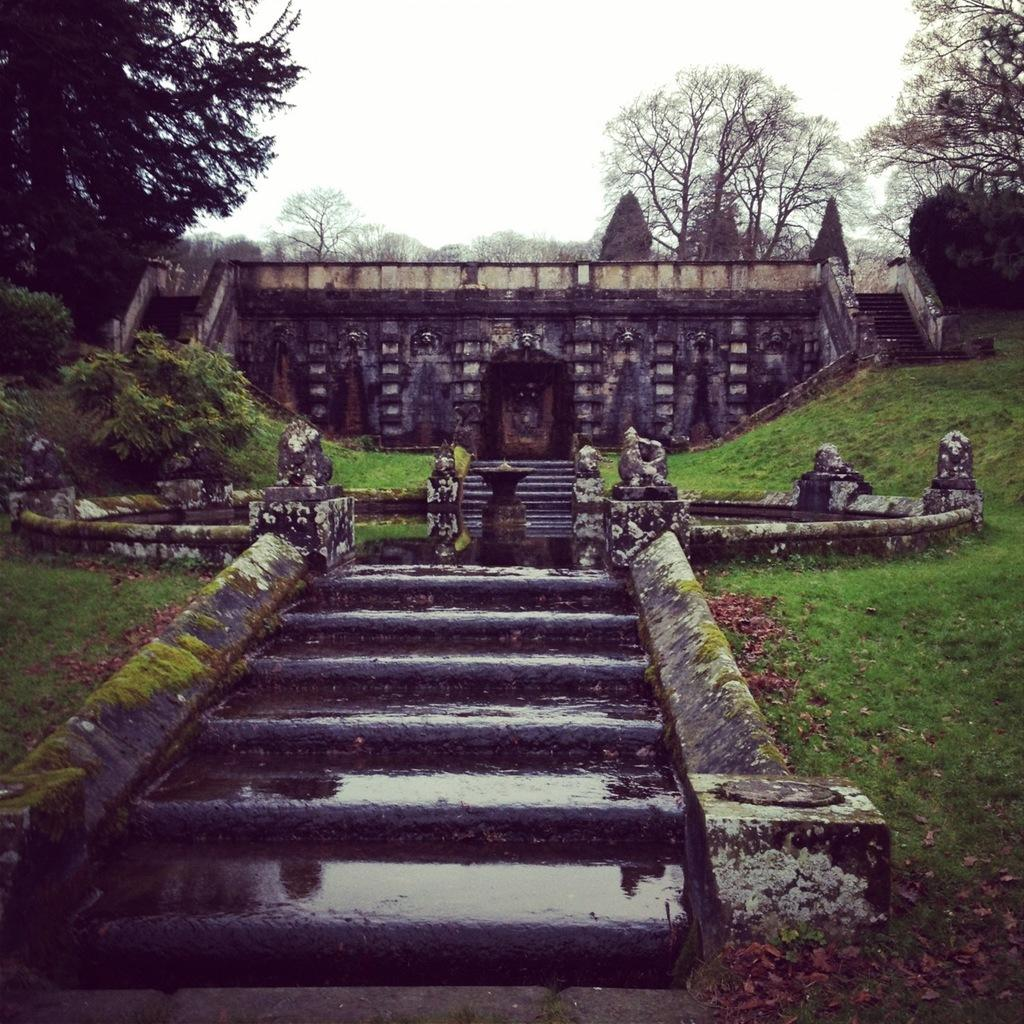What type of vegetation can be seen in the image? There is grass in the image. What architectural feature is present in the image? There are steps in the image. What structure is visible in the image? There is a building in the image. What can be seen in the background of the image? There are trees in the background of the image. What part of the natural environment is visible in the image? The sky is visible in the image. What type of cloth is draped over the horn in the image? There is no cloth or horn present in the image. What time is indicated by the clock in the image? There is no clock present in the image. 